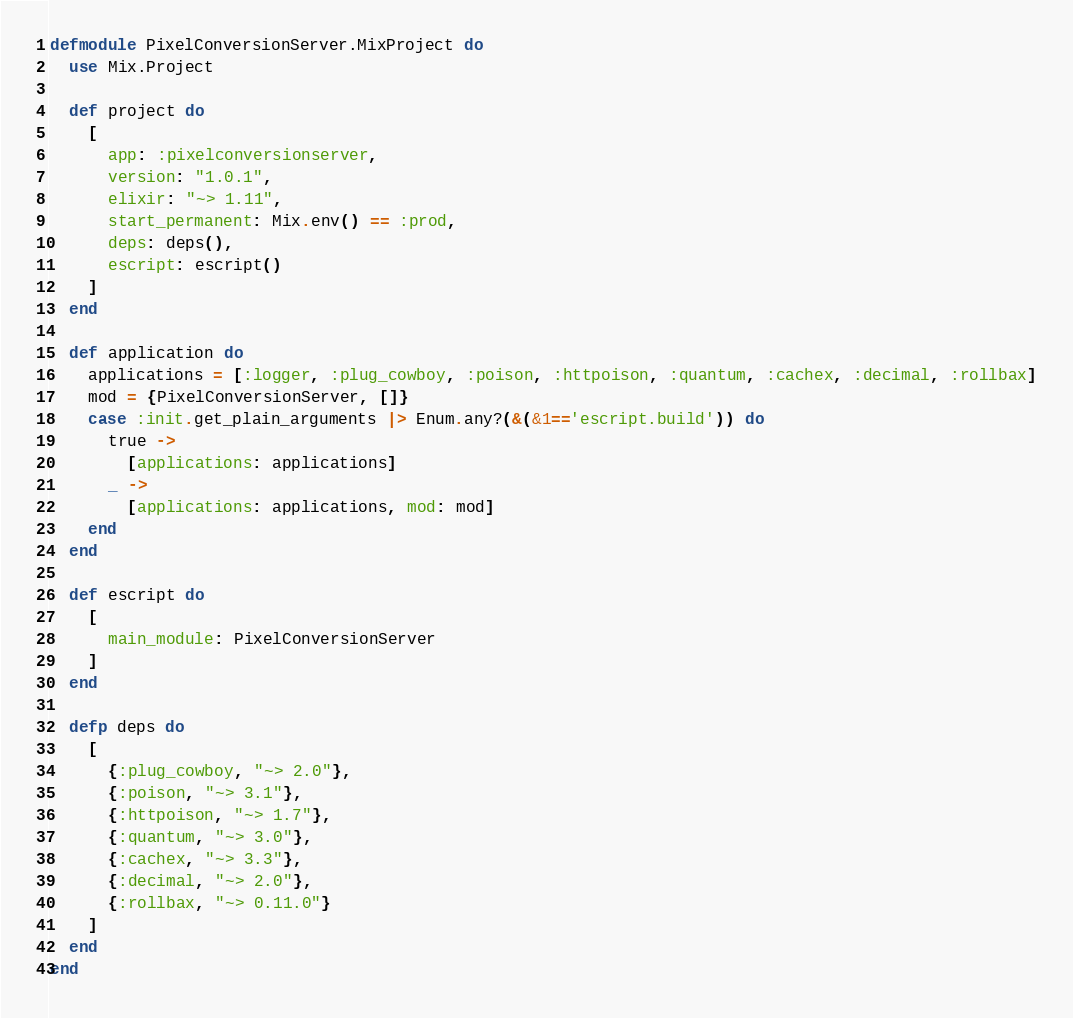Convert code to text. <code><loc_0><loc_0><loc_500><loc_500><_Elixir_>defmodule PixelConversionServer.MixProject do
  use Mix.Project

  def project do
    [
      app: :pixelconversionserver,
      version: "1.0.1",
      elixir: "~> 1.11",
      start_permanent: Mix.env() == :prod,
      deps: deps(),
      escript: escript()
    ]
  end

  def application do
    applications = [:logger, :plug_cowboy, :poison, :httpoison, :quantum, :cachex, :decimal, :rollbax]
    mod = {PixelConversionServer, []}
    case :init.get_plain_arguments |> Enum.any?(&(&1=='escript.build')) do
      true ->
        [applications: applications]
      _ ->
        [applications: applications, mod: mod]
    end
  end

  def escript do
    [
      main_module: PixelConversionServer
    ]
  end

  defp deps do
    [
      {:plug_cowboy, "~> 2.0"},
      {:poison, "~> 3.1"},
      {:httpoison, "~> 1.7"},
      {:quantum, "~> 3.0"},
      {:cachex, "~> 3.3"},
      {:decimal, "~> 2.0"},
      {:rollbax, "~> 0.11.0"}
    ]
  end
end
</code> 